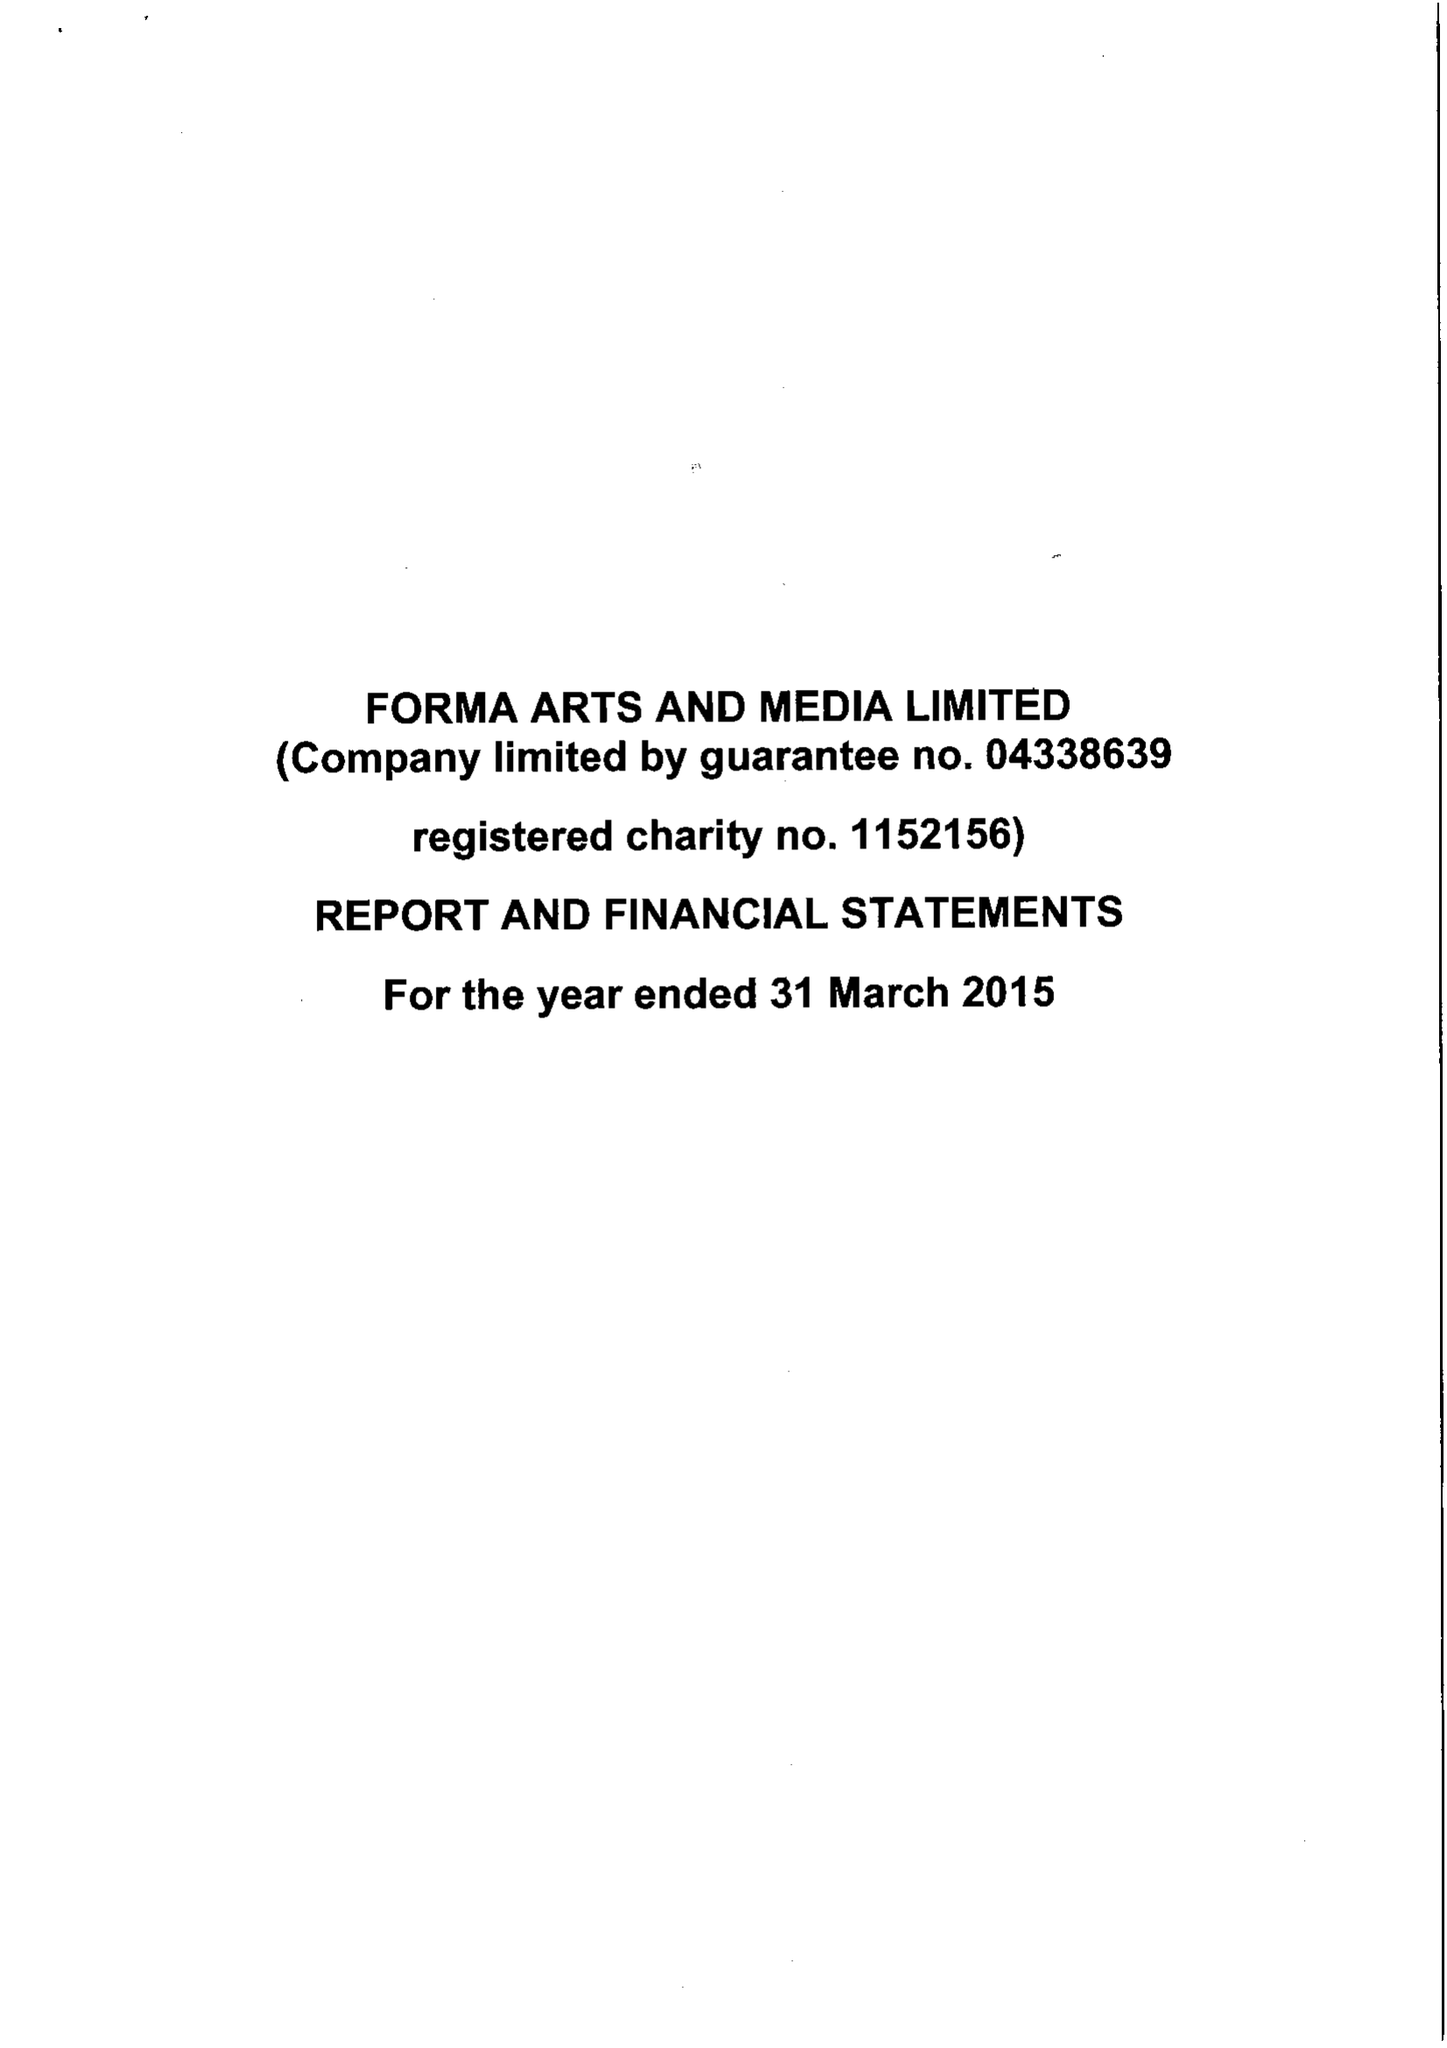What is the value for the address__street_line?
Answer the question using a single word or phrase. None 